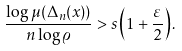<formula> <loc_0><loc_0><loc_500><loc_500>\frac { \log \mu ( \Delta _ { n } ( x ) ) } { n \log \varrho } > s \left ( 1 + \frac { \varepsilon } { 2 } \right ) .</formula> 